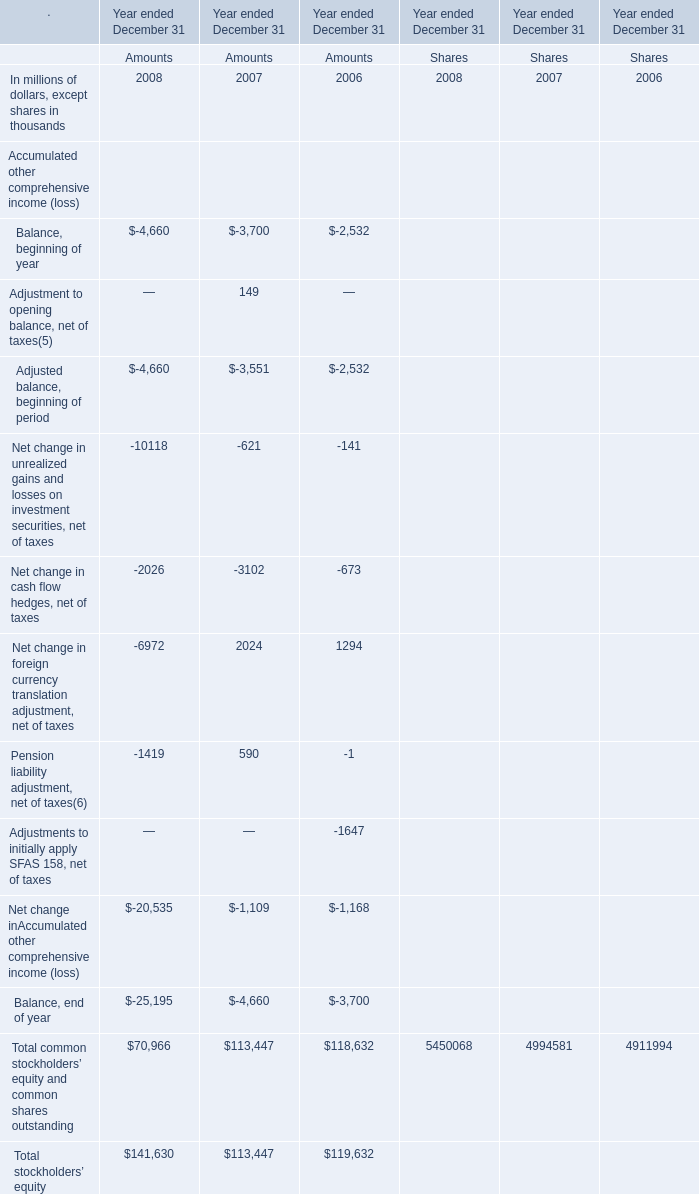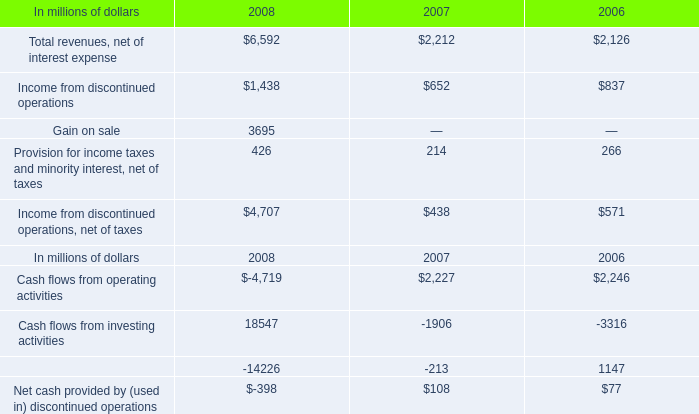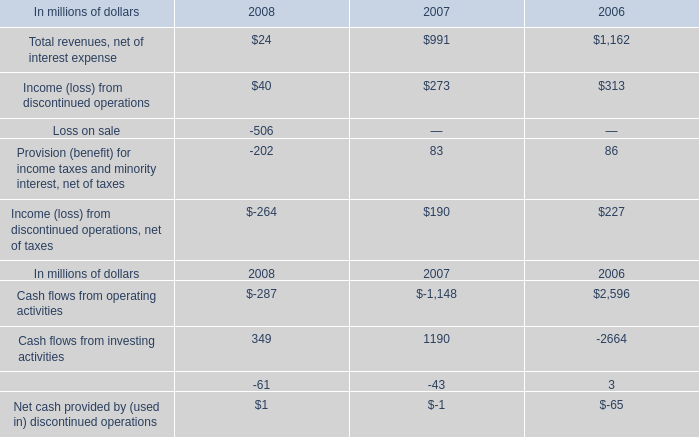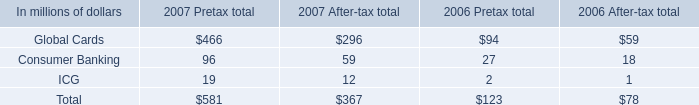What is the sum of Cash flows from investing activities of 2006, and Income from discontinued operations, net of taxes of 2008 ? 
Computations: (2664.0 + 4707.0)
Answer: 7371.0. 